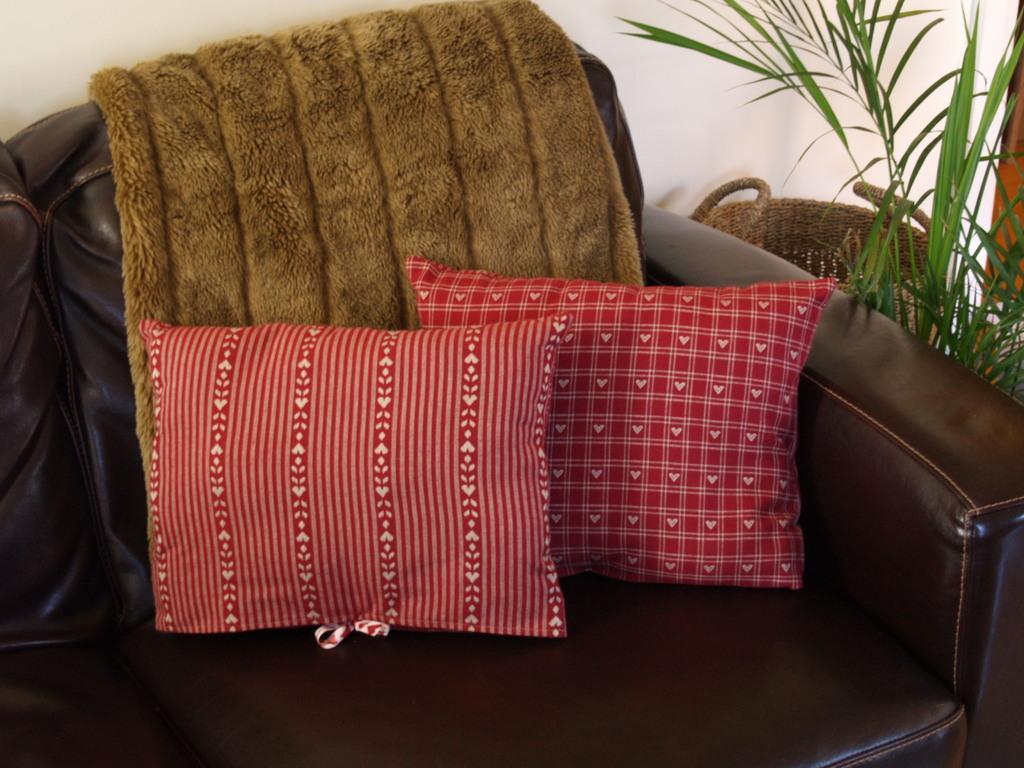Can you describe this image briefly? There is a sofa. There is a pillow and towel on a sofa. We can see in the background there is a wall and plants. 